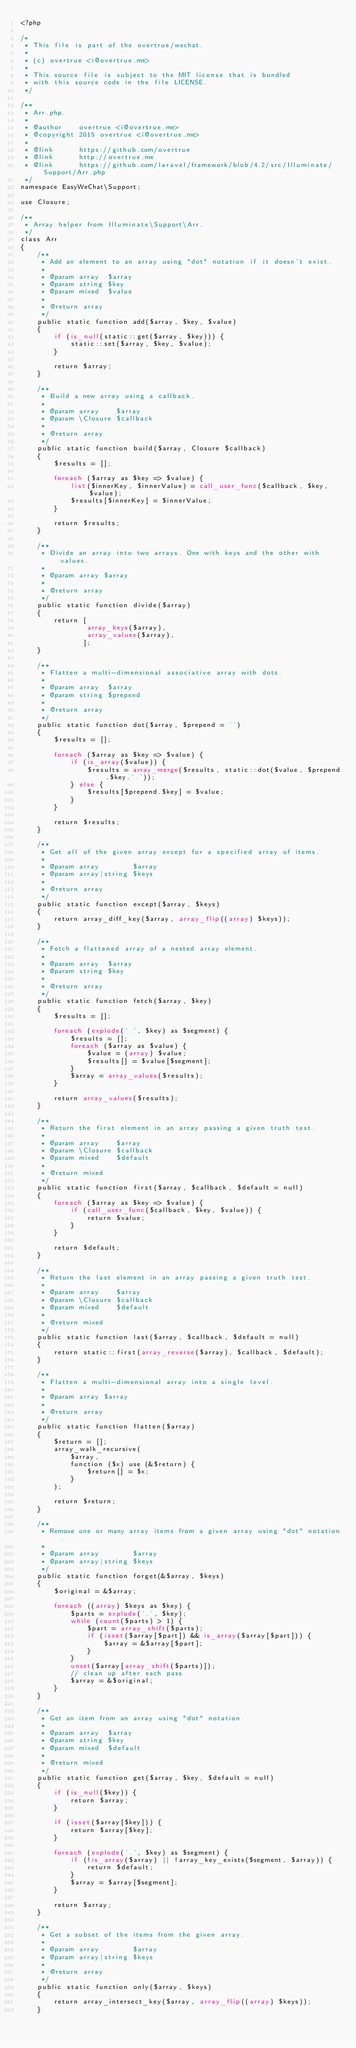<code> <loc_0><loc_0><loc_500><loc_500><_PHP_><?php

/*
 * This file is part of the overtrue/wechat.
 *
 * (c) overtrue <i@overtrue.me>
 *
 * This source file is subject to the MIT license that is bundled
 * with this source code in the file LICENSE.
 */

/**
 * Arr.php.
 *
 * @author    overtrue <i@overtrue.me>
 * @copyright 2015 overtrue <i@overtrue.me>
 *
 * @link      https://github.com/overtrue
 * @link      http://overtrue.me
 * @link      https://github.com/laravel/framework/blob/4.2/src/Illuminate/Support/Arr.php
 */
namespace EasyWeChat\Support;

use Closure;

/**
 * Array helper from Illuminate\Support\Arr.
 */
class Arr
{
    /**
     * Add an element to an array using "dot" notation if it doesn't exist.
     *
     * @param array  $array
     * @param string $key
     * @param mixed  $value
     *
     * @return array
     */
    public static function add($array, $key, $value)
    {
        if (is_null(static::get($array, $key))) {
            static::set($array, $key, $value);
        }

        return $array;
    }

    /**
     * Build a new array using a callback.
     *
     * @param array    $array
     * @param \Closure $callback
     *
     * @return array
     */
    public static function build($array, Closure $callback)
    {
        $results = [];

        foreach ($array as $key => $value) {
            list($innerKey, $innerValue) = call_user_func($callback, $key, $value);
            $results[$innerKey] = $innerValue;
        }

        return $results;
    }

    /**
     * Divide an array into two arrays. One with keys and the other with values.
     *
     * @param array $array
     *
     * @return array
     */
    public static function divide($array)
    {
        return [
                array_keys($array),
                array_values($array),
               ];
    }

    /**
     * Flatten a multi-dimensional associative array with dots.
     *
     * @param array  $array
     * @param string $prepend
     *
     * @return array
     */
    public static function dot($array, $prepend = '')
    {
        $results = [];

        foreach ($array as $key => $value) {
            if (is_array($value)) {
                $results = array_merge($results, static::dot($value, $prepend.$key.'.'));
            } else {
                $results[$prepend.$key] = $value;
            }
        }

        return $results;
    }

    /**
     * Get all of the given array except for a specified array of items.
     *
     * @param array        $array
     * @param array|string $keys
     *
     * @return array
     */
    public static function except($array, $keys)
    {
        return array_diff_key($array, array_flip((array) $keys));
    }

    /**
     * Fetch a flattened array of a nested array element.
     *
     * @param array  $array
     * @param string $key
     *
     * @return array
     */
    public static function fetch($array, $key)
    {
        $results = [];

        foreach (explode('.', $key) as $segment) {
            $results = [];
            foreach ($array as $value) {
                $value = (array) $value;
                $results[] = $value[$segment];
            }
            $array = array_values($results);
        }

        return array_values($results);
    }

    /**
     * Return the first element in an array passing a given truth test.
     *
     * @param array    $array
     * @param \Closure $callback
     * @param mixed    $default
     *
     * @return mixed
     */
    public static function first($array, $callback, $default = null)
    {
        foreach ($array as $key => $value) {
            if (call_user_func($callback, $key, $value)) {
                return $value;
            }
        }

        return $default;
    }

    /**
     * Return the last element in an array passing a given truth test.
     *
     * @param array    $array
     * @param \Closure $callback
     * @param mixed    $default
     *
     * @return mixed
     */
    public static function last($array, $callback, $default = null)
    {
        return static::first(array_reverse($array), $callback, $default);
    }

    /**
     * Flatten a multi-dimensional array into a single level.
     *
     * @param array $array
     *
     * @return array
     */
    public static function flatten($array)
    {
        $return = [];
        array_walk_recursive(
            $array,
            function ($x) use (&$return) {
                $return[] = $x;
            }
        );

        return $return;
    }

    /**
     * Remove one or many array items from a given array using "dot" notation.
     *
     * @param array        $array
     * @param array|string $keys
     */
    public static function forget(&$array, $keys)
    {
        $original = &$array;

        foreach ((array) $keys as $key) {
            $parts = explode('.', $key);
            while (count($parts) > 1) {
                $part = array_shift($parts);
                if (isset($array[$part]) && is_array($array[$part])) {
                    $array = &$array[$part];
                }
            }
            unset($array[array_shift($parts)]);
            // clean up after each pass
            $array = &$original;
        }
    }

    /**
     * Get an item from an array using "dot" notation.
     *
     * @param array  $array
     * @param string $key
     * @param mixed  $default
     *
     * @return mixed
     */
    public static function get($array, $key, $default = null)
    {
        if (is_null($key)) {
            return $array;
        }

        if (isset($array[$key])) {
            return $array[$key];
        }

        foreach (explode('.', $key) as $segment) {
            if (!is_array($array) || !array_key_exists($segment, $array)) {
                return $default;
            }
            $array = $array[$segment];
        }

        return $array;
    }

    /**
     * Get a subset of the items from the given array.
     *
     * @param array        $array
     * @param array|string $keys
     *
     * @return array
     */
    public static function only($array, $keys)
    {
        return array_intersect_key($array, array_flip((array) $keys));
    }
</code> 